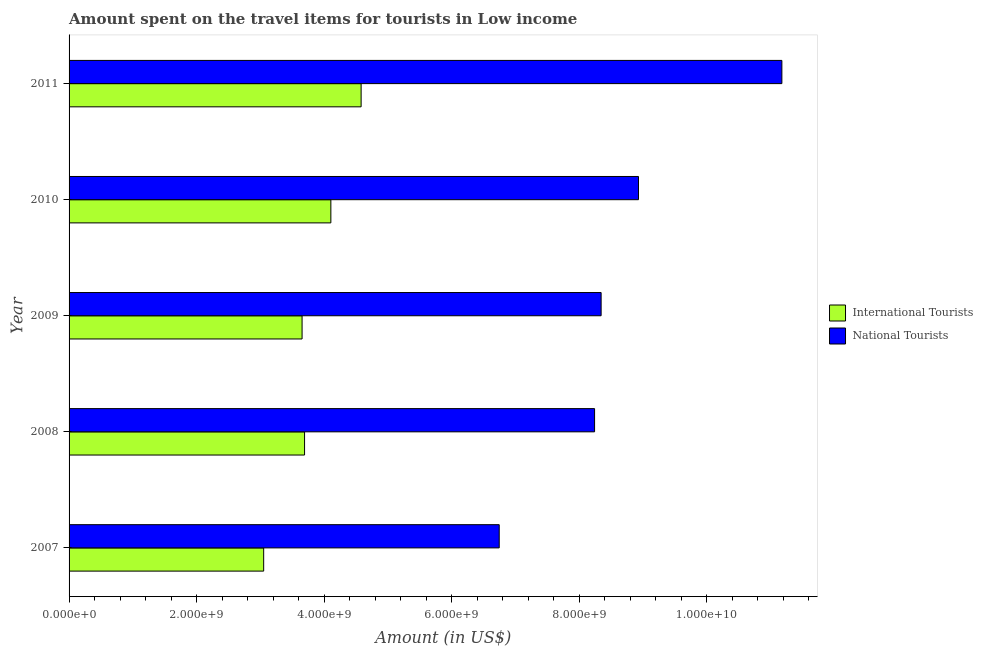In how many cases, is the number of bars for a given year not equal to the number of legend labels?
Provide a short and direct response. 0. What is the amount spent on travel items of international tourists in 2008?
Make the answer very short. 3.69e+09. Across all years, what is the maximum amount spent on travel items of national tourists?
Make the answer very short. 1.12e+1. Across all years, what is the minimum amount spent on travel items of international tourists?
Ensure brevity in your answer.  3.05e+09. What is the total amount spent on travel items of international tourists in the graph?
Provide a short and direct response. 1.91e+1. What is the difference between the amount spent on travel items of international tourists in 2010 and that in 2011?
Your response must be concise. -4.75e+08. What is the difference between the amount spent on travel items of international tourists in 2008 and the amount spent on travel items of national tourists in 2007?
Provide a succinct answer. -3.05e+09. What is the average amount spent on travel items of international tourists per year?
Provide a succinct answer. 3.82e+09. In the year 2007, what is the difference between the amount spent on travel items of international tourists and amount spent on travel items of national tourists?
Provide a succinct answer. -3.70e+09. In how many years, is the amount spent on travel items of national tourists greater than 7600000000 US$?
Keep it short and to the point. 4. Is the amount spent on travel items of international tourists in 2007 less than that in 2009?
Make the answer very short. Yes. Is the difference between the amount spent on travel items of international tourists in 2007 and 2011 greater than the difference between the amount spent on travel items of national tourists in 2007 and 2011?
Give a very brief answer. Yes. What is the difference between the highest and the second highest amount spent on travel items of international tourists?
Your response must be concise. 4.75e+08. What is the difference between the highest and the lowest amount spent on travel items of international tourists?
Offer a terse response. 1.53e+09. In how many years, is the amount spent on travel items of national tourists greater than the average amount spent on travel items of national tourists taken over all years?
Offer a very short reply. 2. What does the 1st bar from the top in 2007 represents?
Ensure brevity in your answer.  National Tourists. What does the 2nd bar from the bottom in 2010 represents?
Your answer should be very brief. National Tourists. How many bars are there?
Offer a very short reply. 10. Are all the bars in the graph horizontal?
Provide a short and direct response. Yes. Does the graph contain any zero values?
Your answer should be very brief. No. Where does the legend appear in the graph?
Your response must be concise. Center right. How are the legend labels stacked?
Your answer should be compact. Vertical. What is the title of the graph?
Give a very brief answer. Amount spent on the travel items for tourists in Low income. Does "DAC donors" appear as one of the legend labels in the graph?
Offer a terse response. No. What is the label or title of the X-axis?
Ensure brevity in your answer.  Amount (in US$). What is the label or title of the Y-axis?
Offer a terse response. Year. What is the Amount (in US$) in International Tourists in 2007?
Keep it short and to the point. 3.05e+09. What is the Amount (in US$) of National Tourists in 2007?
Ensure brevity in your answer.  6.75e+09. What is the Amount (in US$) in International Tourists in 2008?
Make the answer very short. 3.69e+09. What is the Amount (in US$) in National Tourists in 2008?
Offer a terse response. 8.24e+09. What is the Amount (in US$) in International Tourists in 2009?
Keep it short and to the point. 3.66e+09. What is the Amount (in US$) of National Tourists in 2009?
Offer a very short reply. 8.35e+09. What is the Amount (in US$) in International Tourists in 2010?
Your answer should be compact. 4.11e+09. What is the Amount (in US$) in National Tourists in 2010?
Ensure brevity in your answer.  8.93e+09. What is the Amount (in US$) in International Tourists in 2011?
Ensure brevity in your answer.  4.58e+09. What is the Amount (in US$) in National Tourists in 2011?
Ensure brevity in your answer.  1.12e+1. Across all years, what is the maximum Amount (in US$) in International Tourists?
Offer a very short reply. 4.58e+09. Across all years, what is the maximum Amount (in US$) of National Tourists?
Ensure brevity in your answer.  1.12e+1. Across all years, what is the minimum Amount (in US$) in International Tourists?
Make the answer very short. 3.05e+09. Across all years, what is the minimum Amount (in US$) of National Tourists?
Your answer should be compact. 6.75e+09. What is the total Amount (in US$) of International Tourists in the graph?
Provide a succinct answer. 1.91e+1. What is the total Amount (in US$) of National Tourists in the graph?
Provide a short and direct response. 4.35e+1. What is the difference between the Amount (in US$) of International Tourists in 2007 and that in 2008?
Make the answer very short. -6.42e+08. What is the difference between the Amount (in US$) of National Tourists in 2007 and that in 2008?
Offer a terse response. -1.50e+09. What is the difference between the Amount (in US$) of International Tourists in 2007 and that in 2009?
Ensure brevity in your answer.  -6.03e+08. What is the difference between the Amount (in US$) in National Tourists in 2007 and that in 2009?
Give a very brief answer. -1.60e+09. What is the difference between the Amount (in US$) of International Tourists in 2007 and that in 2010?
Give a very brief answer. -1.05e+09. What is the difference between the Amount (in US$) in National Tourists in 2007 and that in 2010?
Keep it short and to the point. -2.18e+09. What is the difference between the Amount (in US$) in International Tourists in 2007 and that in 2011?
Make the answer very short. -1.53e+09. What is the difference between the Amount (in US$) of National Tourists in 2007 and that in 2011?
Your answer should be very brief. -4.43e+09. What is the difference between the Amount (in US$) of International Tourists in 2008 and that in 2009?
Offer a terse response. 3.91e+07. What is the difference between the Amount (in US$) of National Tourists in 2008 and that in 2009?
Give a very brief answer. -1.03e+08. What is the difference between the Amount (in US$) of International Tourists in 2008 and that in 2010?
Offer a terse response. -4.12e+08. What is the difference between the Amount (in US$) of National Tourists in 2008 and that in 2010?
Provide a short and direct response. -6.89e+08. What is the difference between the Amount (in US$) in International Tourists in 2008 and that in 2011?
Keep it short and to the point. -8.87e+08. What is the difference between the Amount (in US$) in National Tourists in 2008 and that in 2011?
Your response must be concise. -2.94e+09. What is the difference between the Amount (in US$) in International Tourists in 2009 and that in 2010?
Provide a short and direct response. -4.51e+08. What is the difference between the Amount (in US$) in National Tourists in 2009 and that in 2010?
Provide a short and direct response. -5.86e+08. What is the difference between the Amount (in US$) in International Tourists in 2009 and that in 2011?
Offer a very short reply. -9.26e+08. What is the difference between the Amount (in US$) of National Tourists in 2009 and that in 2011?
Offer a terse response. -2.84e+09. What is the difference between the Amount (in US$) in International Tourists in 2010 and that in 2011?
Make the answer very short. -4.75e+08. What is the difference between the Amount (in US$) of National Tourists in 2010 and that in 2011?
Your answer should be compact. -2.25e+09. What is the difference between the Amount (in US$) in International Tourists in 2007 and the Amount (in US$) in National Tourists in 2008?
Ensure brevity in your answer.  -5.19e+09. What is the difference between the Amount (in US$) of International Tourists in 2007 and the Amount (in US$) of National Tourists in 2009?
Give a very brief answer. -5.29e+09. What is the difference between the Amount (in US$) of International Tourists in 2007 and the Amount (in US$) of National Tourists in 2010?
Offer a very short reply. -5.88e+09. What is the difference between the Amount (in US$) in International Tourists in 2007 and the Amount (in US$) in National Tourists in 2011?
Offer a very short reply. -8.13e+09. What is the difference between the Amount (in US$) of International Tourists in 2008 and the Amount (in US$) of National Tourists in 2009?
Your answer should be very brief. -4.65e+09. What is the difference between the Amount (in US$) in International Tourists in 2008 and the Amount (in US$) in National Tourists in 2010?
Provide a succinct answer. -5.24e+09. What is the difference between the Amount (in US$) in International Tourists in 2008 and the Amount (in US$) in National Tourists in 2011?
Provide a short and direct response. -7.49e+09. What is the difference between the Amount (in US$) of International Tourists in 2009 and the Amount (in US$) of National Tourists in 2010?
Your answer should be compact. -5.28e+09. What is the difference between the Amount (in US$) in International Tourists in 2009 and the Amount (in US$) in National Tourists in 2011?
Ensure brevity in your answer.  -7.53e+09. What is the difference between the Amount (in US$) in International Tourists in 2010 and the Amount (in US$) in National Tourists in 2011?
Offer a very short reply. -7.07e+09. What is the average Amount (in US$) of International Tourists per year?
Your answer should be compact. 3.82e+09. What is the average Amount (in US$) in National Tourists per year?
Your answer should be very brief. 8.69e+09. In the year 2007, what is the difference between the Amount (in US$) in International Tourists and Amount (in US$) in National Tourists?
Give a very brief answer. -3.70e+09. In the year 2008, what is the difference between the Amount (in US$) of International Tourists and Amount (in US$) of National Tourists?
Offer a terse response. -4.55e+09. In the year 2009, what is the difference between the Amount (in US$) in International Tourists and Amount (in US$) in National Tourists?
Ensure brevity in your answer.  -4.69e+09. In the year 2010, what is the difference between the Amount (in US$) of International Tourists and Amount (in US$) of National Tourists?
Offer a terse response. -4.83e+09. In the year 2011, what is the difference between the Amount (in US$) of International Tourists and Amount (in US$) of National Tourists?
Ensure brevity in your answer.  -6.60e+09. What is the ratio of the Amount (in US$) of International Tourists in 2007 to that in 2008?
Ensure brevity in your answer.  0.83. What is the ratio of the Amount (in US$) in National Tourists in 2007 to that in 2008?
Offer a very short reply. 0.82. What is the ratio of the Amount (in US$) in International Tourists in 2007 to that in 2009?
Ensure brevity in your answer.  0.84. What is the ratio of the Amount (in US$) of National Tourists in 2007 to that in 2009?
Keep it short and to the point. 0.81. What is the ratio of the Amount (in US$) of International Tourists in 2007 to that in 2010?
Your answer should be compact. 0.74. What is the ratio of the Amount (in US$) of National Tourists in 2007 to that in 2010?
Give a very brief answer. 0.76. What is the ratio of the Amount (in US$) of International Tourists in 2007 to that in 2011?
Give a very brief answer. 0.67. What is the ratio of the Amount (in US$) of National Tourists in 2007 to that in 2011?
Provide a succinct answer. 0.6. What is the ratio of the Amount (in US$) of International Tourists in 2008 to that in 2009?
Offer a terse response. 1.01. What is the ratio of the Amount (in US$) of National Tourists in 2008 to that in 2009?
Offer a terse response. 0.99. What is the ratio of the Amount (in US$) in International Tourists in 2008 to that in 2010?
Offer a terse response. 0.9. What is the ratio of the Amount (in US$) in National Tourists in 2008 to that in 2010?
Give a very brief answer. 0.92. What is the ratio of the Amount (in US$) of International Tourists in 2008 to that in 2011?
Give a very brief answer. 0.81. What is the ratio of the Amount (in US$) in National Tourists in 2008 to that in 2011?
Make the answer very short. 0.74. What is the ratio of the Amount (in US$) in International Tourists in 2009 to that in 2010?
Your answer should be compact. 0.89. What is the ratio of the Amount (in US$) of National Tourists in 2009 to that in 2010?
Keep it short and to the point. 0.93. What is the ratio of the Amount (in US$) of International Tourists in 2009 to that in 2011?
Offer a very short reply. 0.8. What is the ratio of the Amount (in US$) in National Tourists in 2009 to that in 2011?
Ensure brevity in your answer.  0.75. What is the ratio of the Amount (in US$) in International Tourists in 2010 to that in 2011?
Keep it short and to the point. 0.9. What is the ratio of the Amount (in US$) of National Tourists in 2010 to that in 2011?
Give a very brief answer. 0.8. What is the difference between the highest and the second highest Amount (in US$) of International Tourists?
Give a very brief answer. 4.75e+08. What is the difference between the highest and the second highest Amount (in US$) of National Tourists?
Ensure brevity in your answer.  2.25e+09. What is the difference between the highest and the lowest Amount (in US$) of International Tourists?
Provide a succinct answer. 1.53e+09. What is the difference between the highest and the lowest Amount (in US$) in National Tourists?
Provide a short and direct response. 4.43e+09. 